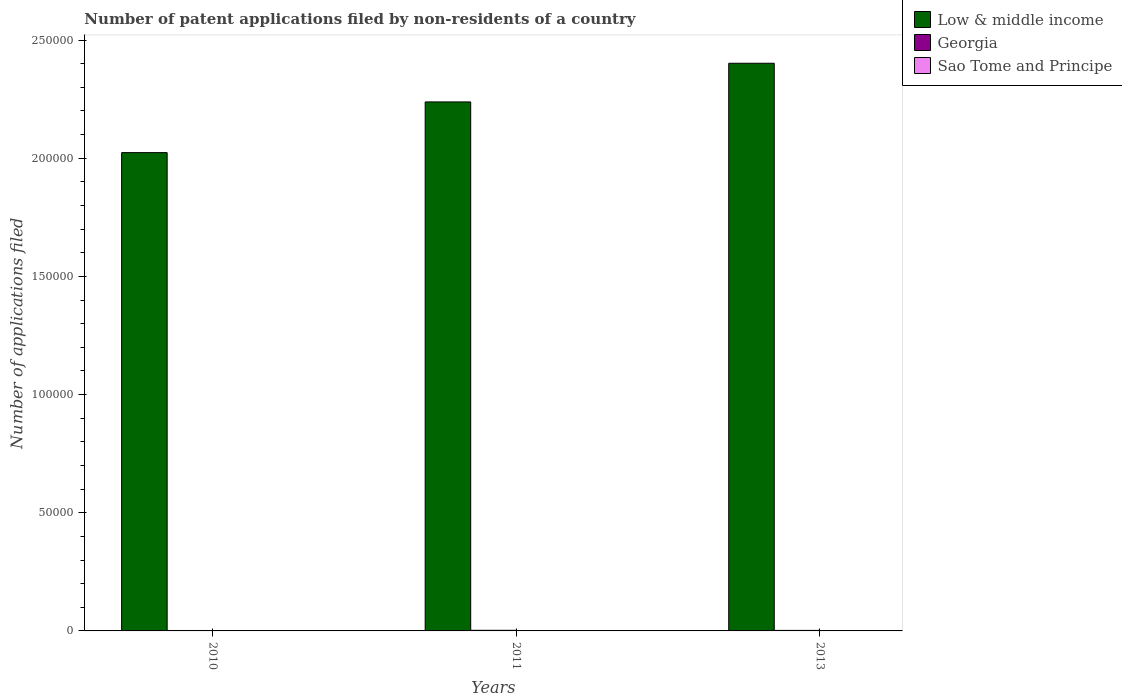How many different coloured bars are there?
Make the answer very short. 3. How many groups of bars are there?
Your response must be concise. 3. In how many cases, is the number of bars for a given year not equal to the number of legend labels?
Make the answer very short. 0. What is the number of applications filed in Sao Tome and Principe in 2010?
Your answer should be very brief. 1. Across all years, what is the maximum number of applications filed in Georgia?
Offer a terse response. 260. Across all years, what is the minimum number of applications filed in Georgia?
Offer a very short reply. 179. In which year was the number of applications filed in Low & middle income minimum?
Provide a short and direct response. 2010. What is the total number of applications filed in Georgia in the graph?
Ensure brevity in your answer.  658. What is the difference between the number of applications filed in Georgia in 2011 and the number of applications filed in Low & middle income in 2010?
Your answer should be compact. -2.02e+05. What is the average number of applications filed in Low & middle income per year?
Your answer should be very brief. 2.22e+05. In the year 2011, what is the difference between the number of applications filed in Sao Tome and Principe and number of applications filed in Georgia?
Make the answer very short. -258. What is the ratio of the number of applications filed in Georgia in 2010 to that in 2013?
Your response must be concise. 0.82. What is the difference between the highest and the lowest number of applications filed in Low & middle income?
Your response must be concise. 3.78e+04. What does the 2nd bar from the left in 2011 represents?
Ensure brevity in your answer.  Georgia. What does the 2nd bar from the right in 2010 represents?
Make the answer very short. Georgia. Is it the case that in every year, the sum of the number of applications filed in Georgia and number of applications filed in Sao Tome and Principe is greater than the number of applications filed in Low & middle income?
Provide a succinct answer. No. Are all the bars in the graph horizontal?
Keep it short and to the point. No. What is the difference between two consecutive major ticks on the Y-axis?
Offer a very short reply. 5.00e+04. Are the values on the major ticks of Y-axis written in scientific E-notation?
Offer a very short reply. No. What is the title of the graph?
Make the answer very short. Number of patent applications filed by non-residents of a country. Does "Kenya" appear as one of the legend labels in the graph?
Your answer should be compact. No. What is the label or title of the Y-axis?
Provide a succinct answer. Number of applications filed. What is the Number of applications filed in Low & middle income in 2010?
Keep it short and to the point. 2.02e+05. What is the Number of applications filed of Georgia in 2010?
Offer a very short reply. 179. What is the Number of applications filed of Low & middle income in 2011?
Keep it short and to the point. 2.24e+05. What is the Number of applications filed in Georgia in 2011?
Provide a short and direct response. 260. What is the Number of applications filed of Sao Tome and Principe in 2011?
Provide a succinct answer. 2. What is the Number of applications filed of Low & middle income in 2013?
Your answer should be very brief. 2.40e+05. What is the Number of applications filed of Georgia in 2013?
Make the answer very short. 219. What is the Number of applications filed in Sao Tome and Principe in 2013?
Provide a succinct answer. 8. Across all years, what is the maximum Number of applications filed in Low & middle income?
Ensure brevity in your answer.  2.40e+05. Across all years, what is the maximum Number of applications filed of Georgia?
Provide a succinct answer. 260. Across all years, what is the maximum Number of applications filed in Sao Tome and Principe?
Your answer should be compact. 8. Across all years, what is the minimum Number of applications filed in Low & middle income?
Keep it short and to the point. 2.02e+05. Across all years, what is the minimum Number of applications filed in Georgia?
Your answer should be compact. 179. Across all years, what is the minimum Number of applications filed in Sao Tome and Principe?
Your response must be concise. 1. What is the total Number of applications filed of Low & middle income in the graph?
Ensure brevity in your answer.  6.66e+05. What is the total Number of applications filed of Georgia in the graph?
Offer a very short reply. 658. What is the difference between the Number of applications filed in Low & middle income in 2010 and that in 2011?
Ensure brevity in your answer.  -2.14e+04. What is the difference between the Number of applications filed of Georgia in 2010 and that in 2011?
Give a very brief answer. -81. What is the difference between the Number of applications filed of Sao Tome and Principe in 2010 and that in 2011?
Make the answer very short. -1. What is the difference between the Number of applications filed in Low & middle income in 2010 and that in 2013?
Offer a very short reply. -3.78e+04. What is the difference between the Number of applications filed of Georgia in 2010 and that in 2013?
Make the answer very short. -40. What is the difference between the Number of applications filed in Low & middle income in 2011 and that in 2013?
Your answer should be compact. -1.64e+04. What is the difference between the Number of applications filed of Georgia in 2011 and that in 2013?
Give a very brief answer. 41. What is the difference between the Number of applications filed of Low & middle income in 2010 and the Number of applications filed of Georgia in 2011?
Your answer should be compact. 2.02e+05. What is the difference between the Number of applications filed of Low & middle income in 2010 and the Number of applications filed of Sao Tome and Principe in 2011?
Your response must be concise. 2.02e+05. What is the difference between the Number of applications filed of Georgia in 2010 and the Number of applications filed of Sao Tome and Principe in 2011?
Ensure brevity in your answer.  177. What is the difference between the Number of applications filed in Low & middle income in 2010 and the Number of applications filed in Georgia in 2013?
Your answer should be very brief. 2.02e+05. What is the difference between the Number of applications filed of Low & middle income in 2010 and the Number of applications filed of Sao Tome and Principe in 2013?
Give a very brief answer. 2.02e+05. What is the difference between the Number of applications filed of Georgia in 2010 and the Number of applications filed of Sao Tome and Principe in 2013?
Your response must be concise. 171. What is the difference between the Number of applications filed in Low & middle income in 2011 and the Number of applications filed in Georgia in 2013?
Make the answer very short. 2.24e+05. What is the difference between the Number of applications filed in Low & middle income in 2011 and the Number of applications filed in Sao Tome and Principe in 2013?
Provide a succinct answer. 2.24e+05. What is the difference between the Number of applications filed in Georgia in 2011 and the Number of applications filed in Sao Tome and Principe in 2013?
Your answer should be compact. 252. What is the average Number of applications filed of Low & middle income per year?
Give a very brief answer. 2.22e+05. What is the average Number of applications filed of Georgia per year?
Your answer should be compact. 219.33. What is the average Number of applications filed in Sao Tome and Principe per year?
Provide a succinct answer. 3.67. In the year 2010, what is the difference between the Number of applications filed of Low & middle income and Number of applications filed of Georgia?
Ensure brevity in your answer.  2.02e+05. In the year 2010, what is the difference between the Number of applications filed of Low & middle income and Number of applications filed of Sao Tome and Principe?
Keep it short and to the point. 2.02e+05. In the year 2010, what is the difference between the Number of applications filed of Georgia and Number of applications filed of Sao Tome and Principe?
Provide a short and direct response. 178. In the year 2011, what is the difference between the Number of applications filed in Low & middle income and Number of applications filed in Georgia?
Your answer should be compact. 2.24e+05. In the year 2011, what is the difference between the Number of applications filed of Low & middle income and Number of applications filed of Sao Tome and Principe?
Give a very brief answer. 2.24e+05. In the year 2011, what is the difference between the Number of applications filed of Georgia and Number of applications filed of Sao Tome and Principe?
Offer a terse response. 258. In the year 2013, what is the difference between the Number of applications filed of Low & middle income and Number of applications filed of Georgia?
Offer a terse response. 2.40e+05. In the year 2013, what is the difference between the Number of applications filed of Low & middle income and Number of applications filed of Sao Tome and Principe?
Make the answer very short. 2.40e+05. In the year 2013, what is the difference between the Number of applications filed in Georgia and Number of applications filed in Sao Tome and Principe?
Make the answer very short. 211. What is the ratio of the Number of applications filed of Low & middle income in 2010 to that in 2011?
Provide a short and direct response. 0.9. What is the ratio of the Number of applications filed of Georgia in 2010 to that in 2011?
Make the answer very short. 0.69. What is the ratio of the Number of applications filed of Sao Tome and Principe in 2010 to that in 2011?
Offer a very short reply. 0.5. What is the ratio of the Number of applications filed in Low & middle income in 2010 to that in 2013?
Your answer should be compact. 0.84. What is the ratio of the Number of applications filed in Georgia in 2010 to that in 2013?
Keep it short and to the point. 0.82. What is the ratio of the Number of applications filed of Low & middle income in 2011 to that in 2013?
Provide a succinct answer. 0.93. What is the ratio of the Number of applications filed in Georgia in 2011 to that in 2013?
Provide a succinct answer. 1.19. What is the ratio of the Number of applications filed in Sao Tome and Principe in 2011 to that in 2013?
Keep it short and to the point. 0.25. What is the difference between the highest and the second highest Number of applications filed in Low & middle income?
Provide a short and direct response. 1.64e+04. What is the difference between the highest and the second highest Number of applications filed of Georgia?
Keep it short and to the point. 41. What is the difference between the highest and the second highest Number of applications filed of Sao Tome and Principe?
Make the answer very short. 6. What is the difference between the highest and the lowest Number of applications filed of Low & middle income?
Your answer should be very brief. 3.78e+04. 